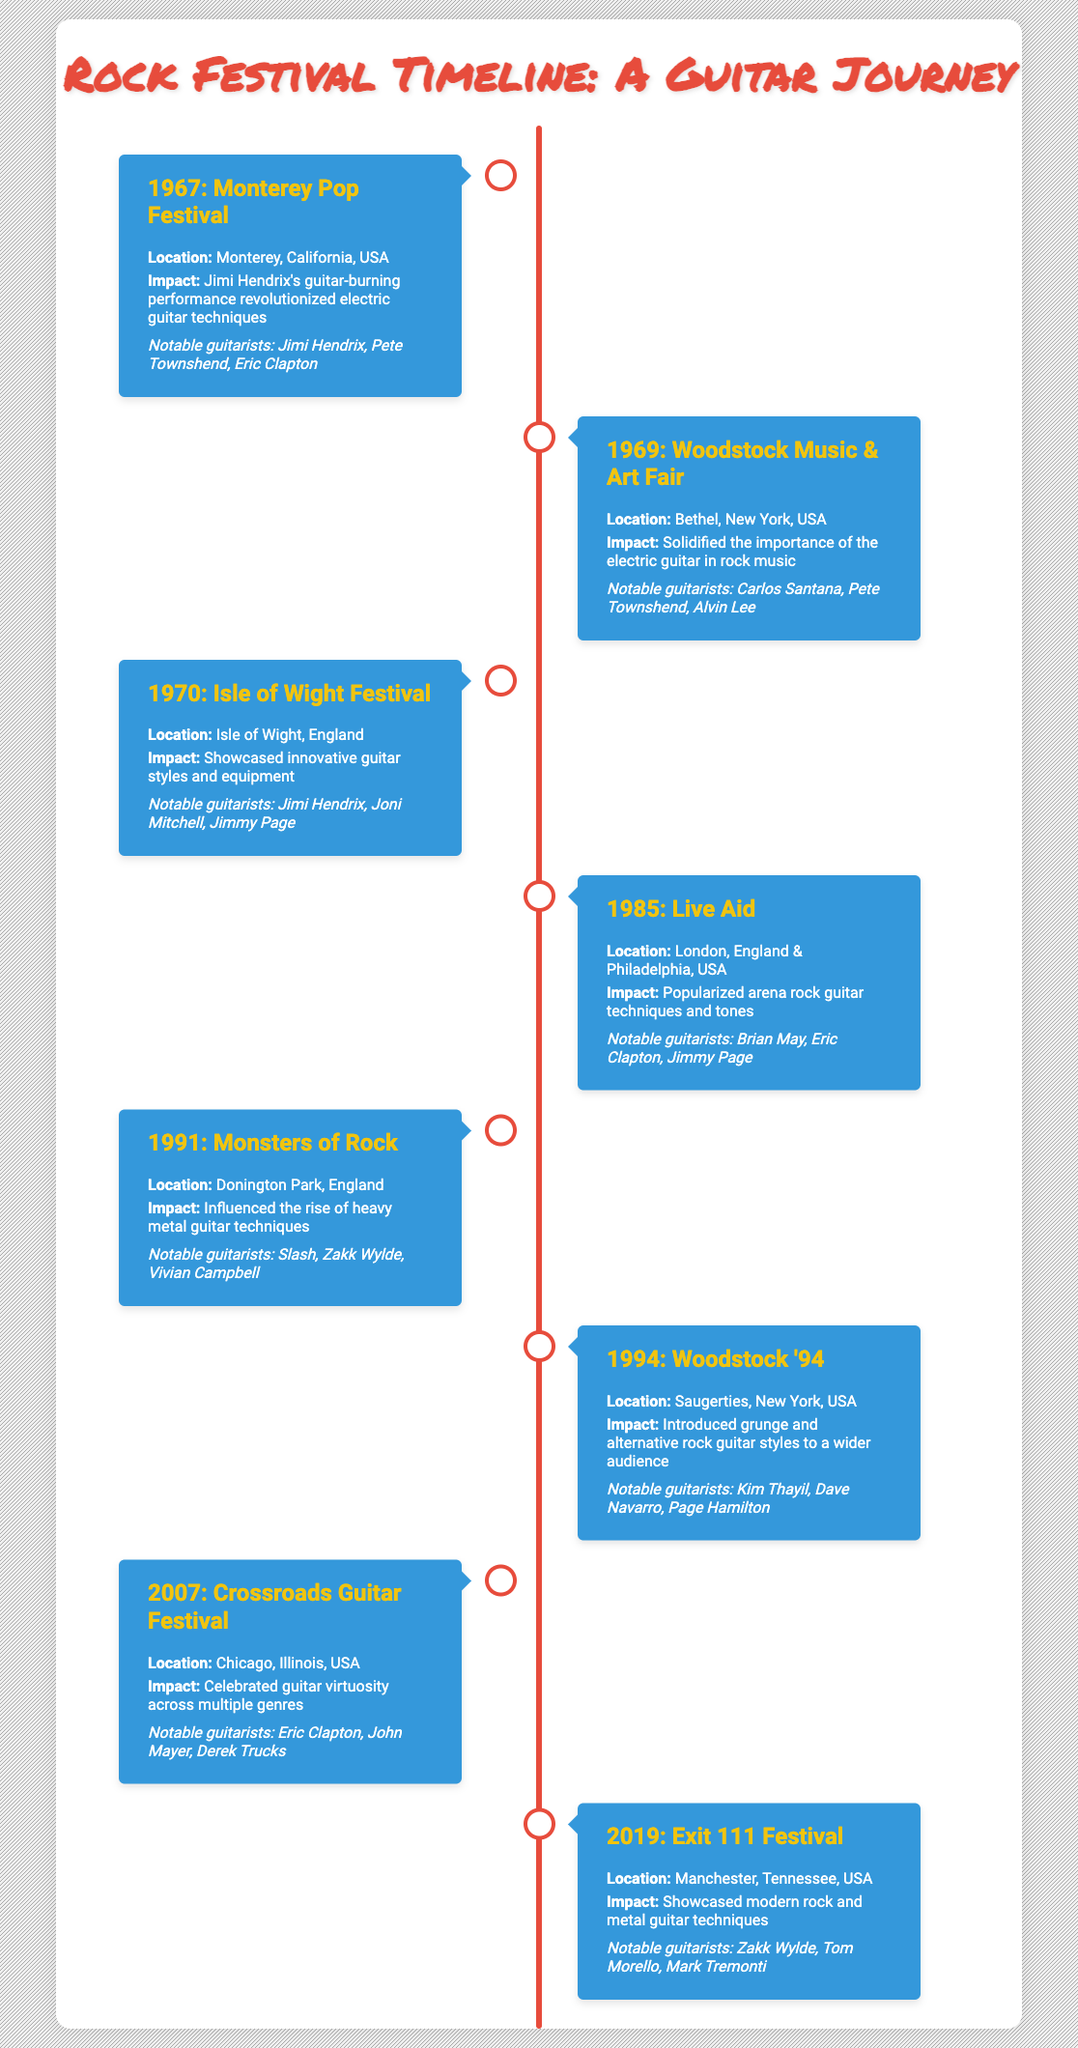What guitar techniques were popularized at the 1985 Live Aid concert? The 1985 Live Aid concert popularized arena rock guitar techniques and tones, as stated in the impact section of the event.
Answer: Arena rock guitar techniques and tones Which guitarist performed at both the Monterey Pop Festival in 1967 and the Isle of Wight Festival in 1970? Jimi Hendrix is listed as a notable guitarist for both the Monterey Pop Festival in 1967 and the Isle of Wight Festival in 1970.
Answer: Jimi Hendrix How many guitarists were noted as performers at the Woodstock '94 festival? The notable guitarists listed for Woodstock '94 are Kim Thayil, Dave Navarro, and Page Hamilton, totaling three guitarists.
Answer: Three Did the Isle of Wight Festival showcase innovative guitar styles? Yes, the impact of the Isle of Wight Festival in 1970 explicitly mentions the showcasing of innovative guitar styles and equipment.
Answer: Yes What is the earliest year mentioned in the timeline, and what event corresponds with it? The earliest year mentioned is 1967, which corresponds with the Monterey Pop Festival event.
Answer: 1967: Monterey Pop Festival Which event was closest in year to the introduction of grunge guitar styles? Woodstock '94 in 1994 introduced grunge and alternative rock guitar styles. By comparing the years between the listed events, Woodstock '94 is the event closest to this introduction.
Answer: Woodstock '94 List all the notable guitarists associated with the 1991 Monsters of Rock festival. The notable guitarists mentioned for the 1991 Monsters of Rock are Slash, Zakk Wylde, and Vivian Campbell.
Answer: Slash, Zakk Wylde, Vivian Campbell Which festival is associated with the electric guitar's solidification in rock music? The Woodstock Music & Art Fair in 1969 is associated with solidifying the importance of the electric guitar in rock music, as stated in its impact.
Answer: Woodstock Music & Art Fair Count the number of major rock festivals listed that took place before the year 2000. Events before 2000 include the festivals in 1967, 1969, 1970, 1985, 1991, and 1994, totaling six events.
Answer: Six 